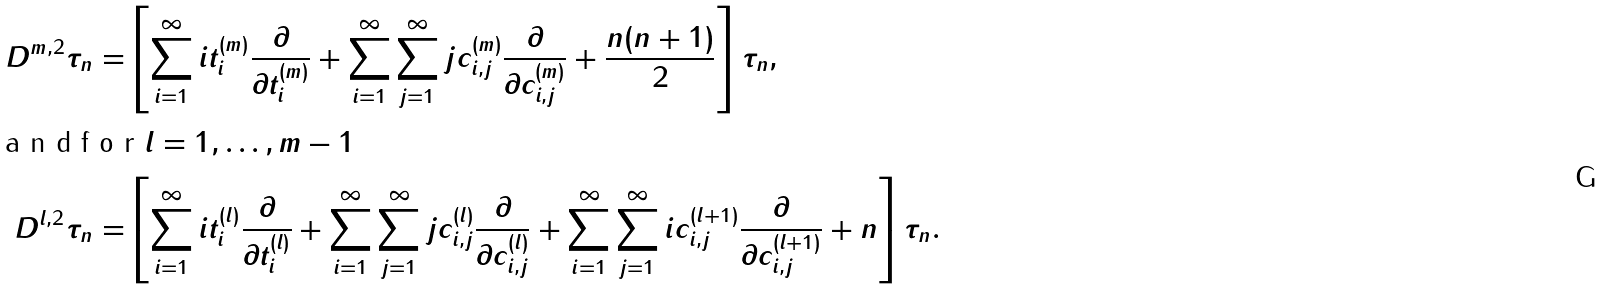Convert formula to latex. <formula><loc_0><loc_0><loc_500><loc_500>D ^ { m , 2 } \tau _ { n } = & \left [ \sum ^ { \infty } _ { i = 1 } i t ^ { ( m ) } _ { i } \frac { \partial } { \partial t ^ { ( m ) } _ { i } } + \sum ^ { \infty } _ { i = 1 } \sum ^ { \infty } _ { j = 1 } j c ^ { ( m ) } _ { i , j } \frac { \partial } { \partial c ^ { ( m ) } _ { i , j } } + \frac { n ( n + 1 ) } { 2 } \right ] \tau _ { n } , \\ \intertext { a n d f o r $ l = 1 , \dots , m - 1 $ } D ^ { l , 2 } \tau _ { n } = & \left [ \sum ^ { \infty } _ { i = 1 } i t ^ { ( l ) } _ { i } \frac { \partial } { \partial t ^ { ( l ) } _ { i } } + \sum ^ { \infty } _ { i = 1 } \sum ^ { \infty } _ { j = 1 } j c ^ { ( l ) } _ { i , j } \frac { \partial } { \partial c ^ { ( l ) } _ { i , j } } + \sum ^ { \infty } _ { i = 1 } \sum ^ { \infty } _ { j = 1 } i c ^ { ( l + 1 ) } _ { i , j } \frac { \partial } { \partial c ^ { ( l + 1 ) } _ { i , j } } + n \right ] \tau _ { n } .</formula> 